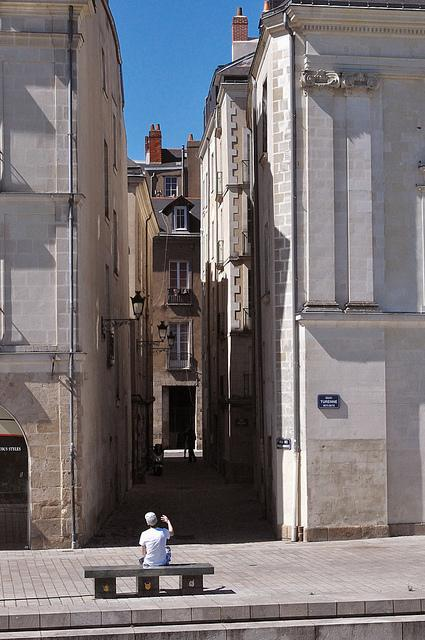Why does the man seated have his arm up?

Choices:
A) measure
B) balance
C) gesture
D) break fall gesture 